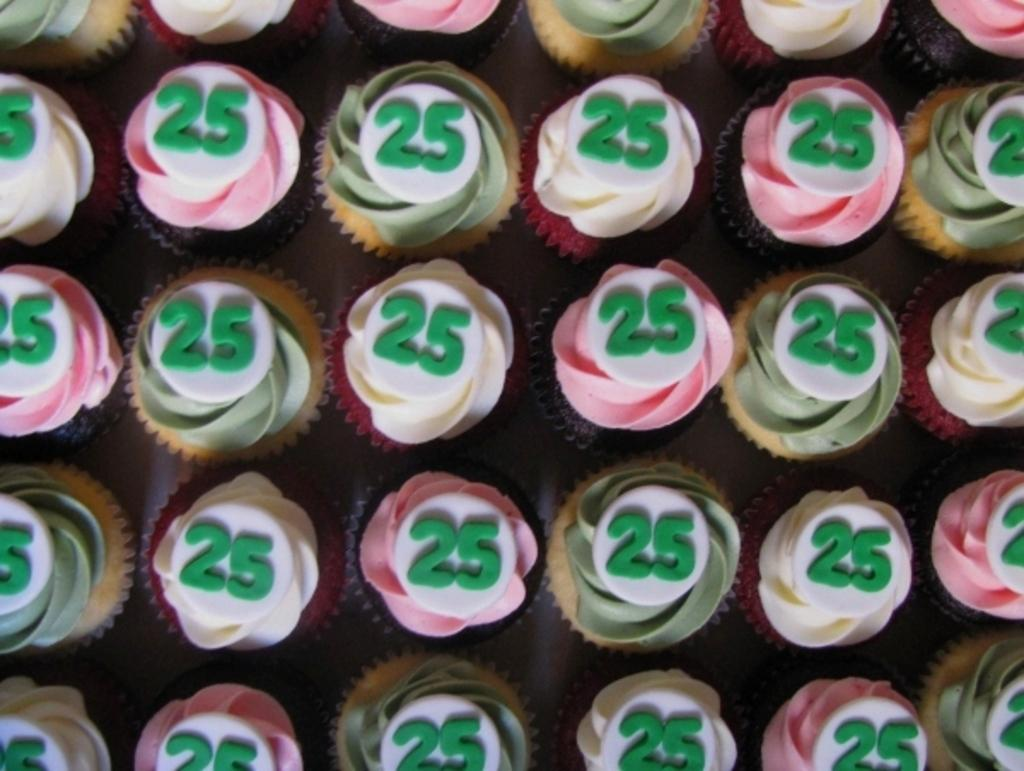What type of food is visible in the image? There are cupcakes in the image. What additional detail can be observed on the cupcakes? There are numbers on the cupcakes. What type of can is shown in the image? There is no can present in the image; it features cupcakes with numbers on them. What historical event is depicted in the image? There is no historical event depicted in the image; it features cupcakes with numbers on them. 